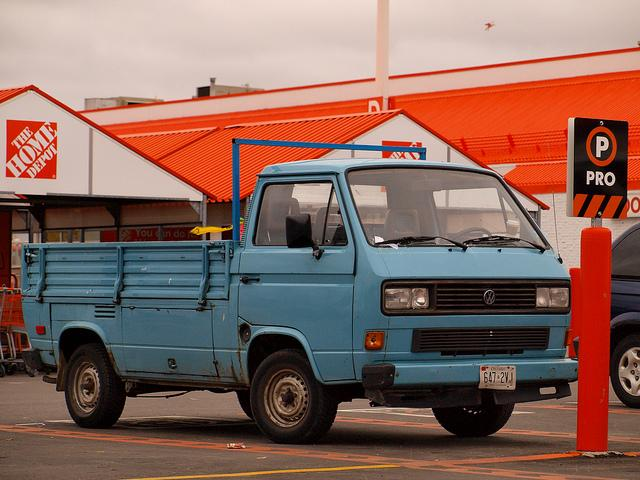What does the store to the left sell? home goods 